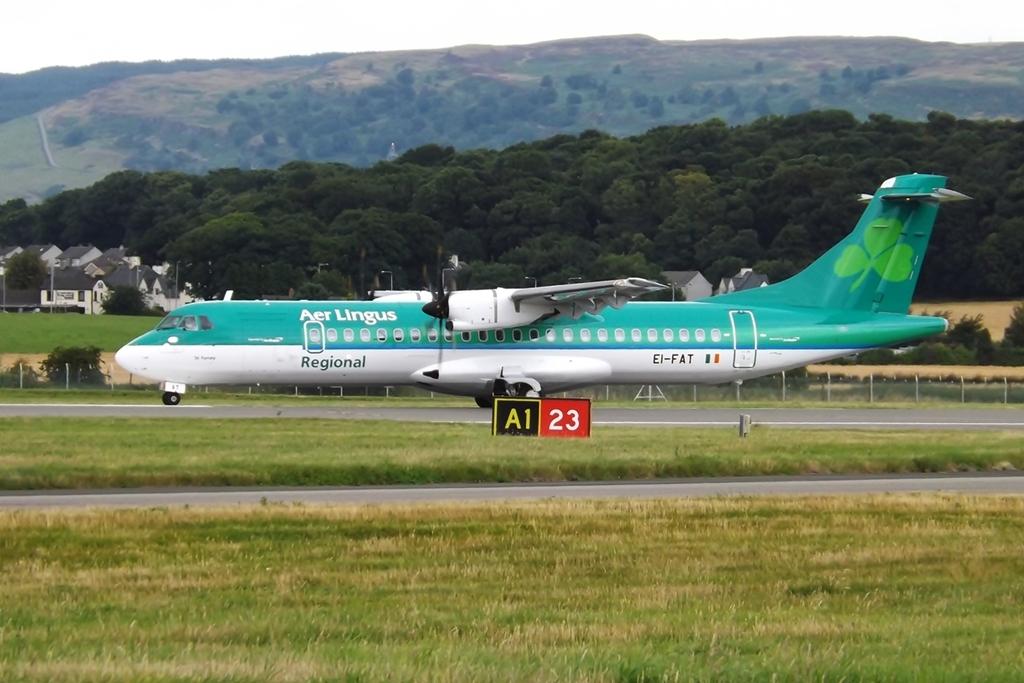What airline is this plane?
Keep it short and to the point. Aer lingus. What number is on the red square?
Your answer should be compact. 23. 